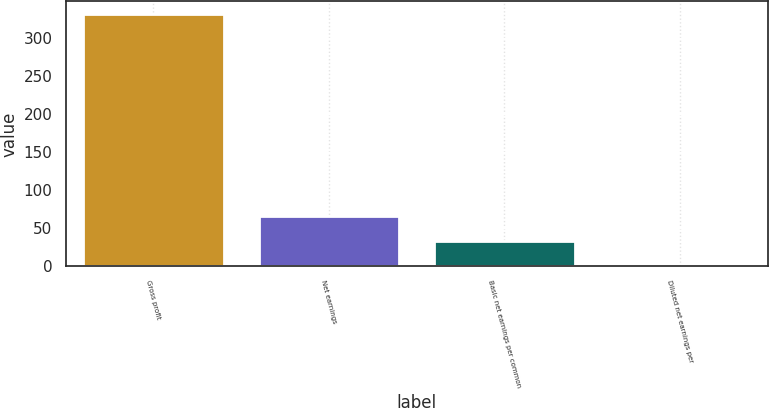Convert chart to OTSL. <chart><loc_0><loc_0><loc_500><loc_500><bar_chart><fcel>Gross profit<fcel>Net earnings<fcel>Basic net earnings per common<fcel>Diluted net earnings per<nl><fcel>331.8<fcel>66.59<fcel>33.44<fcel>0.29<nl></chart> 